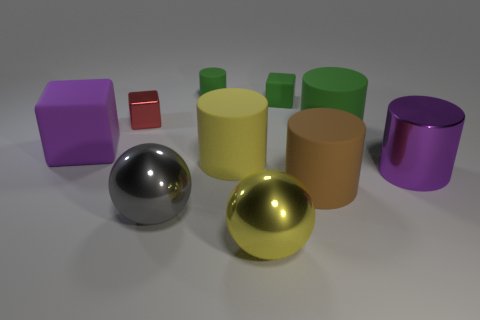Subtract all purple cylinders. How many cylinders are left? 4 Subtract all big purple metal cylinders. How many cylinders are left? 4 Subtract all brown cylinders. Subtract all brown spheres. How many cylinders are left? 4 Subtract all balls. How many objects are left? 8 Subtract all green blocks. Subtract all tiny red shiny blocks. How many objects are left? 8 Add 8 brown objects. How many brown objects are left? 9 Add 6 small metallic cubes. How many small metallic cubes exist? 7 Subtract 0 cyan cylinders. How many objects are left? 10 